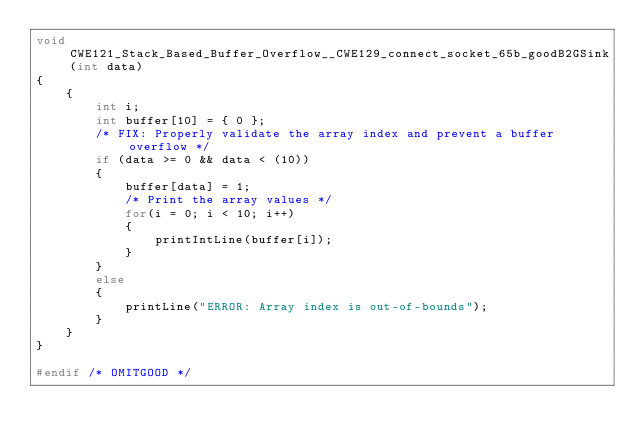<code> <loc_0><loc_0><loc_500><loc_500><_C_>void CWE121_Stack_Based_Buffer_Overflow__CWE129_connect_socket_65b_goodB2GSink(int data)
{
    {
        int i;
        int buffer[10] = { 0 };
        /* FIX: Properly validate the array index and prevent a buffer overflow */
        if (data >= 0 && data < (10))
        {
            buffer[data] = 1;
            /* Print the array values */
            for(i = 0; i < 10; i++)
            {
                printIntLine(buffer[i]);
            }
        }
        else
        {
            printLine("ERROR: Array index is out-of-bounds");
        }
    }
}

#endif /* OMITGOOD */
</code> 